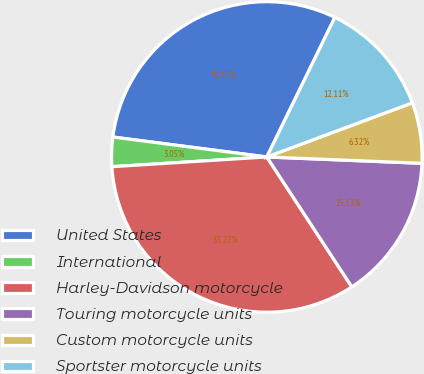Convert chart to OTSL. <chart><loc_0><loc_0><loc_500><loc_500><pie_chart><fcel>United States<fcel>International<fcel>Harley-Davidson motorcycle<fcel>Touring motorcycle units<fcel>Custom motorcycle units<fcel>Sportster motorcycle units<nl><fcel>30.17%<fcel>3.05%<fcel>33.22%<fcel>15.13%<fcel>6.32%<fcel>12.11%<nl></chart> 